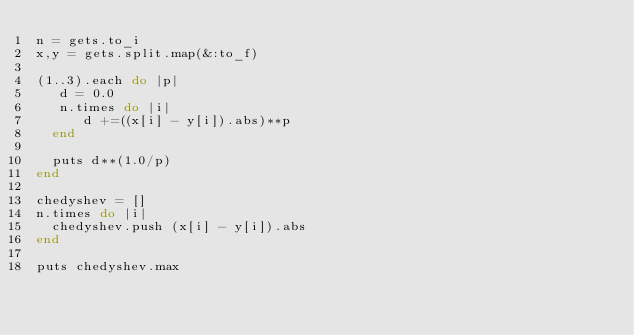Convert code to text. <code><loc_0><loc_0><loc_500><loc_500><_Ruby_>n = gets.to_i
x,y = gets.split.map(&:to_f)

(1..3).each do |p|
   d = 0.0
   n.times do |i|
      d +=((x[i] - y[i]).abs)**p
  end
  
  puts d**(1.0/p)
end

chedyshev = []
n.times do |i|
  chedyshev.push (x[i] - y[i]).abs
end

puts chedyshev.max</code> 